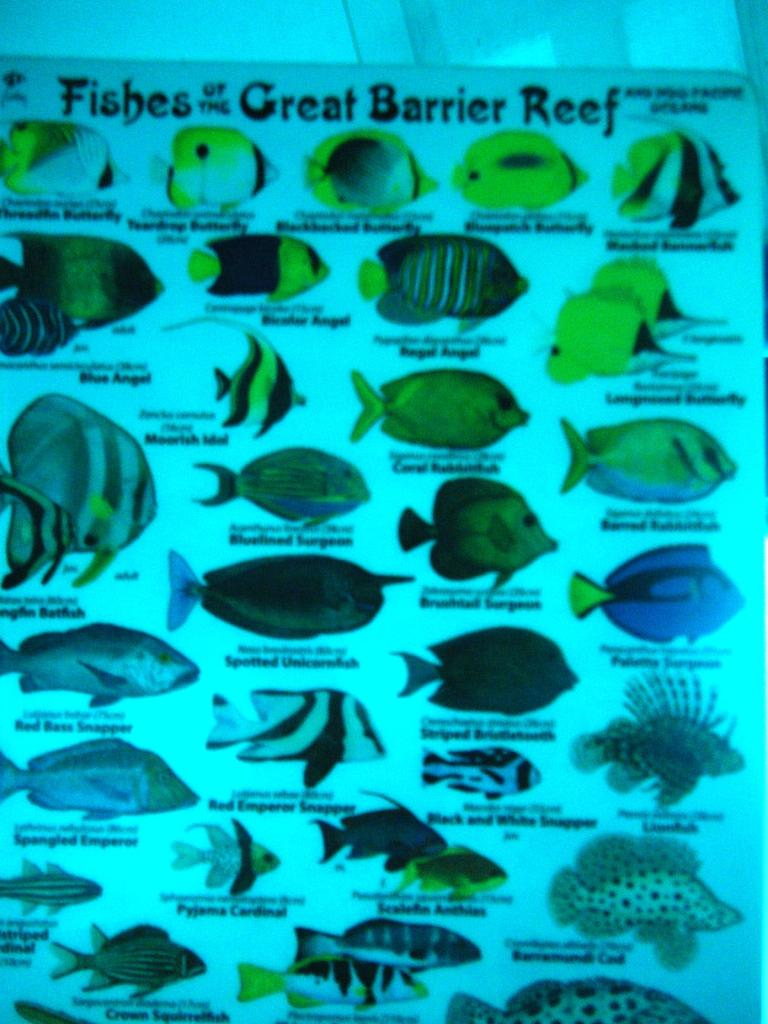What is the main subject of the image? The main subject of the image is a fishes chart. What types of information can be found on the chart? The chart contains different kinds of fishes and their names. What type of appliance can be seen in the image? There is no appliance present in the image; it features a fishes chart with different kinds of fishes and their names. What scent is associated with the fishes in the image? There is no mention of scent in the image; it only contains a chart with information about different kinds of fishes. 